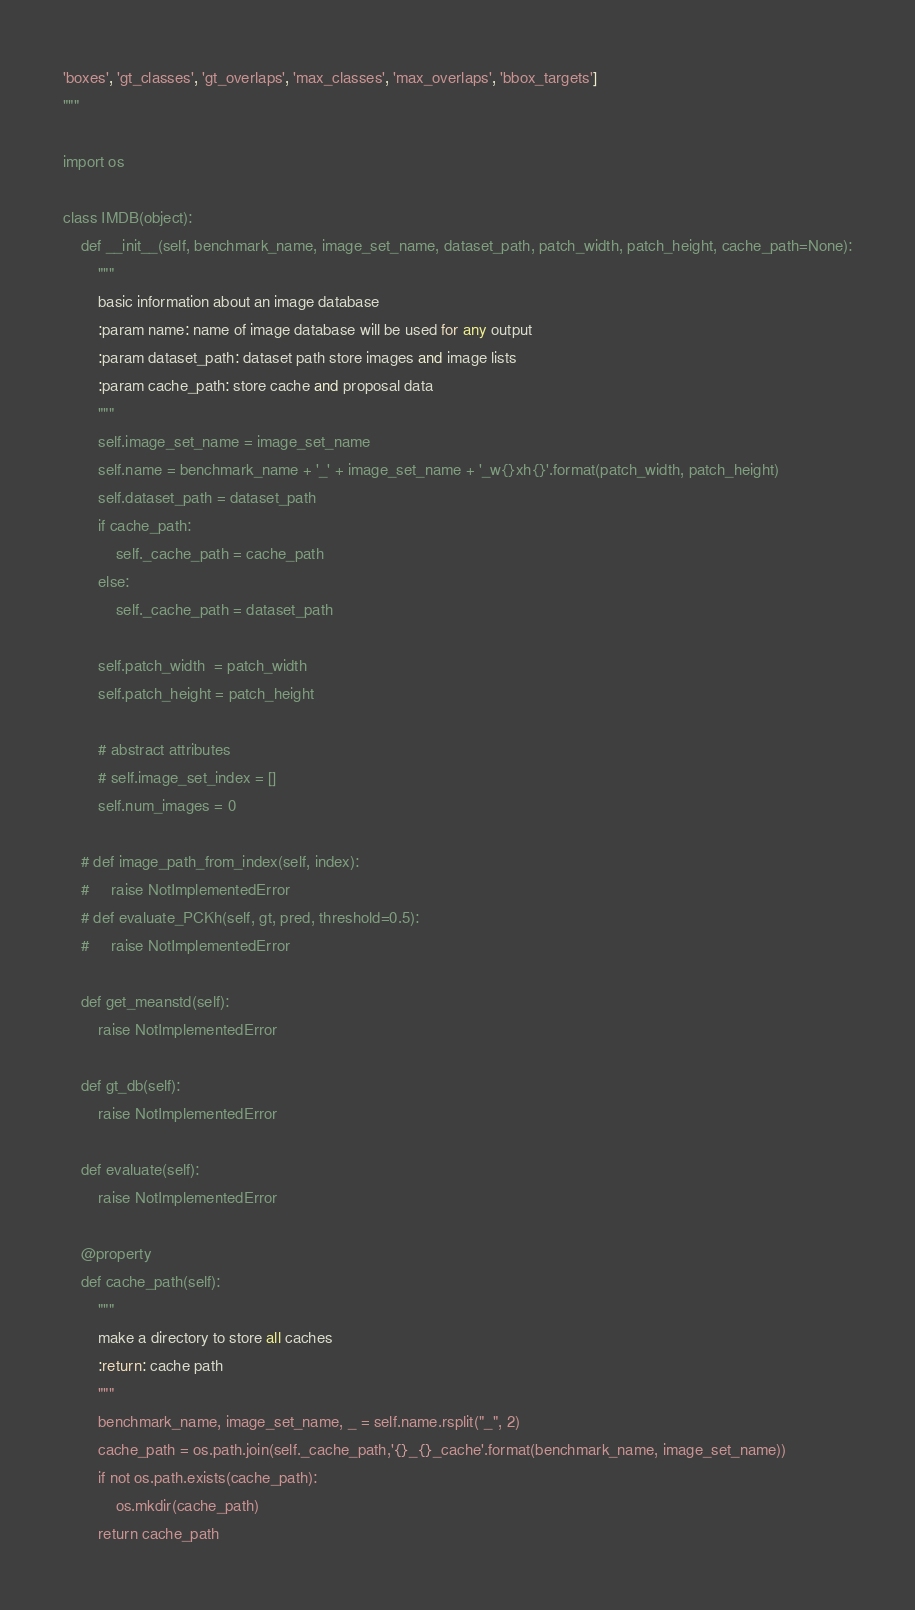Convert code to text. <code><loc_0><loc_0><loc_500><loc_500><_Python_>'boxes', 'gt_classes', 'gt_overlaps', 'max_classes', 'max_overlaps', 'bbox_targets']
"""

import os

class IMDB(object):
    def __init__(self, benchmark_name, image_set_name, dataset_path, patch_width, patch_height, cache_path=None):
        """
        basic information about an image database
        :param name: name of image database will be used for any output
        :param dataset_path: dataset path store images and image lists
        :param cache_path: store cache and proposal data
        """
        self.image_set_name = image_set_name
        self.name = benchmark_name + '_' + image_set_name + '_w{}xh{}'.format(patch_width, patch_height)
        self.dataset_path = dataset_path
        if cache_path:
            self._cache_path = cache_path
        else:
            self._cache_path = dataset_path

        self.patch_width  = patch_width
        self.patch_height = patch_height

        # abstract attributes
        # self.image_set_index = []
        self.num_images = 0

    # def image_path_from_index(self, index):
    #     raise NotImplementedError
    # def evaluate_PCKh(self, gt, pred, threshold=0.5):
    #     raise NotImplementedError

    def get_meanstd(self):
        raise NotImplementedError

    def gt_db(self):
        raise NotImplementedError

    def evaluate(self):
        raise NotImplementedError

    @property
    def cache_path(self):
        """
        make a directory to store all caches
        :return: cache path
        """
        benchmark_name, image_set_name, _ = self.name.rsplit("_", 2)
        cache_path = os.path.join(self._cache_path,'{}_{}_cache'.format(benchmark_name, image_set_name))
        if not os.path.exists(cache_path):
            os.mkdir(cache_path)
        return cache_path</code> 